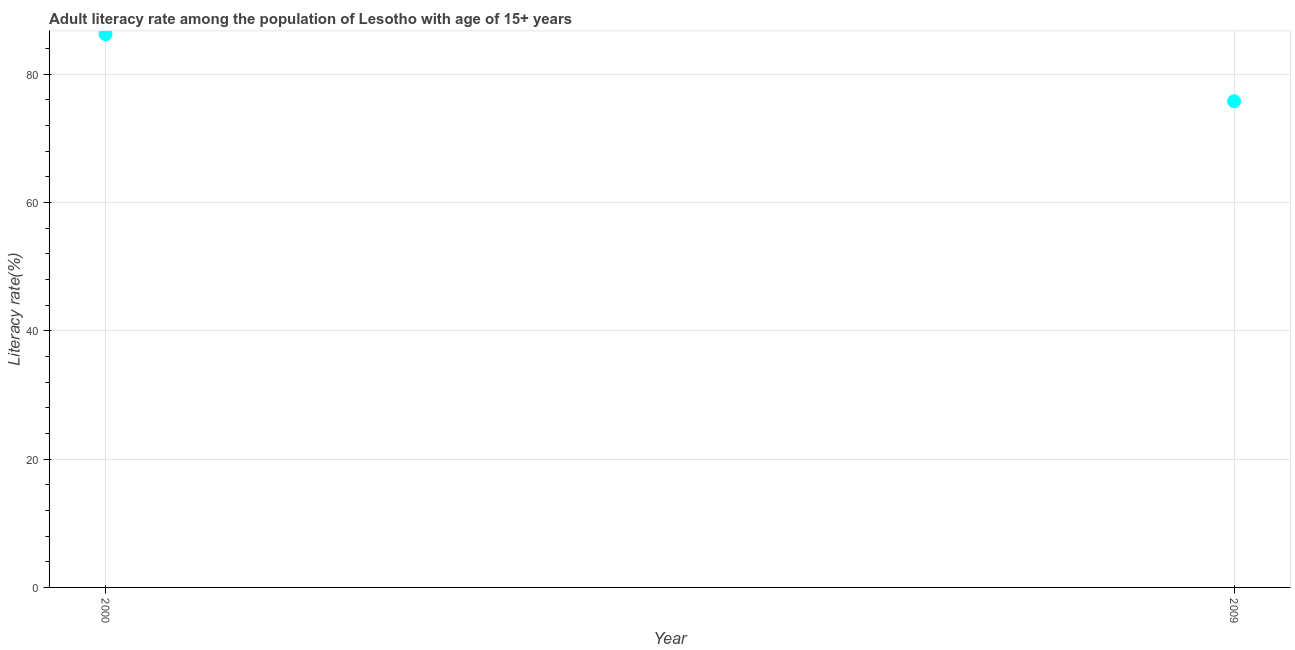What is the adult literacy rate in 2000?
Provide a short and direct response. 86.25. Across all years, what is the maximum adult literacy rate?
Ensure brevity in your answer.  86.25. Across all years, what is the minimum adult literacy rate?
Offer a terse response. 75.8. In which year was the adult literacy rate minimum?
Your answer should be very brief. 2009. What is the sum of the adult literacy rate?
Ensure brevity in your answer.  162.05. What is the difference between the adult literacy rate in 2000 and 2009?
Make the answer very short. 10.45. What is the average adult literacy rate per year?
Offer a terse response. 81.03. What is the median adult literacy rate?
Your response must be concise. 81.03. What is the ratio of the adult literacy rate in 2000 to that in 2009?
Ensure brevity in your answer.  1.14. Is the adult literacy rate in 2000 less than that in 2009?
Provide a short and direct response. No. In how many years, is the adult literacy rate greater than the average adult literacy rate taken over all years?
Provide a succinct answer. 1. Does the adult literacy rate monotonically increase over the years?
Provide a short and direct response. No. How many dotlines are there?
Ensure brevity in your answer.  1. Does the graph contain any zero values?
Provide a short and direct response. No. What is the title of the graph?
Your answer should be very brief. Adult literacy rate among the population of Lesotho with age of 15+ years. What is the label or title of the Y-axis?
Your answer should be compact. Literacy rate(%). What is the Literacy rate(%) in 2000?
Offer a terse response. 86.25. What is the Literacy rate(%) in 2009?
Offer a terse response. 75.8. What is the difference between the Literacy rate(%) in 2000 and 2009?
Offer a very short reply. 10.45. What is the ratio of the Literacy rate(%) in 2000 to that in 2009?
Your answer should be very brief. 1.14. 